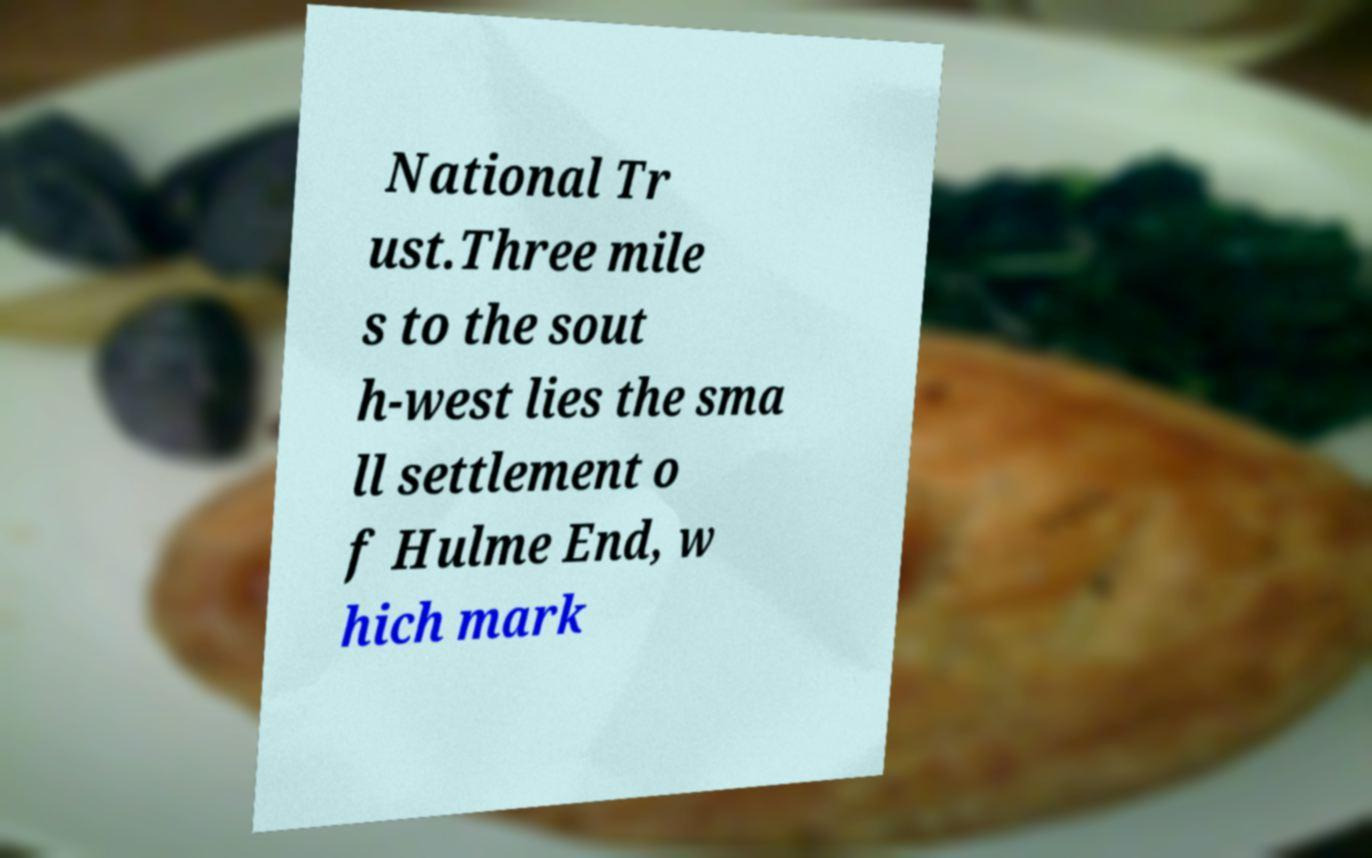What messages or text are displayed in this image? I need them in a readable, typed format. National Tr ust.Three mile s to the sout h-west lies the sma ll settlement o f Hulme End, w hich mark 